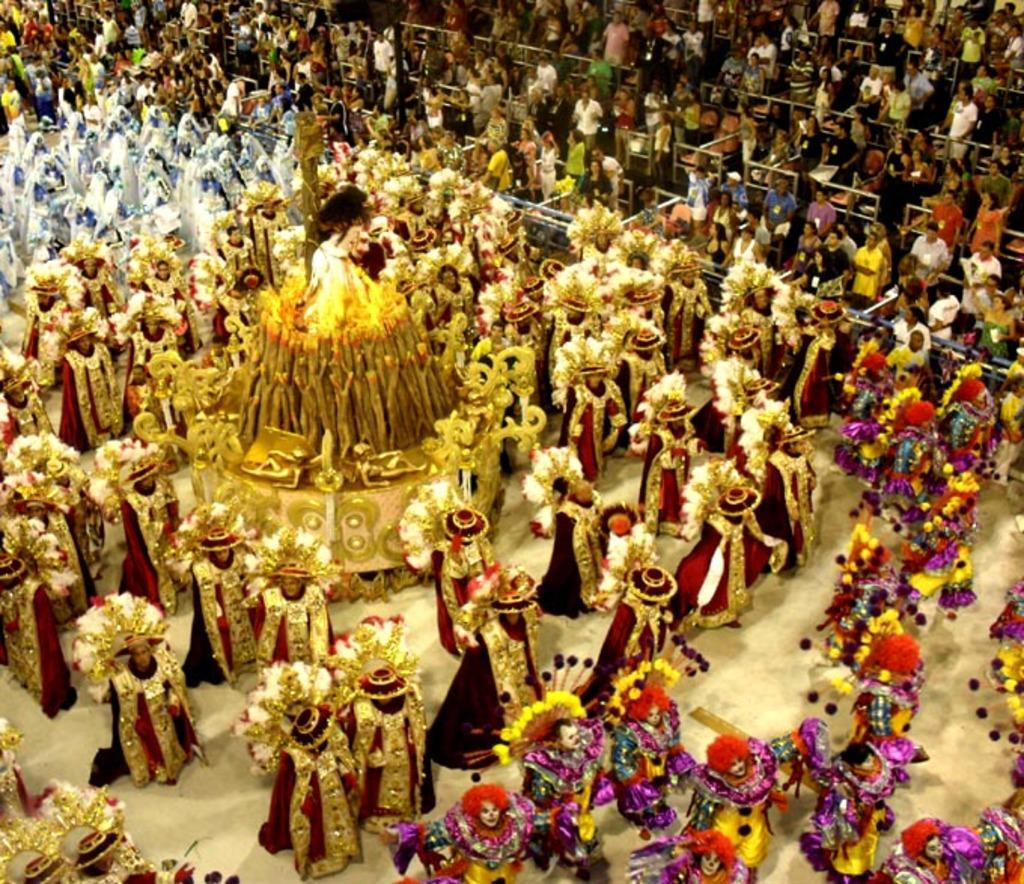What are the people in the image doing? There is a group of people on the ground in the image. What are the people wearing? The people are wearing costumes. Are there any other people visible in the image? Yes, there is a group of people visible in the background of the image. What type of rake is being used by the boy in the image? There is no boy or rake present in the image. 